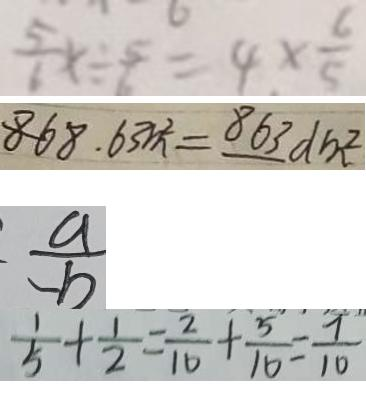<formula> <loc_0><loc_0><loc_500><loc_500>\frac { 5 } { 6 } x \div \frac { 5 } { 6 } = 4 \times \frac { 6 } { 5 } 
 8 6 8 . 6 3 m ^ { 2 } = 8 6 3 d m ^ { 2 } 
 \frac { a } { - b } 
 \frac { 1 } { 5 } + \frac { 1 } { 2 } = \frac { 2 } { 1 0 } + \frac { 5 } { 1 0 } = \frac { 7 } { 1 0 }</formula> 